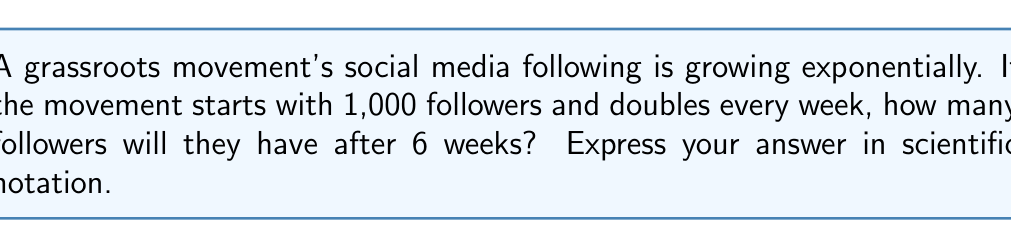Could you help me with this problem? Let's approach this step-by-step:

1) The initial number of followers is 1,000.

2) The number of followers doubles every week, which means we're multiplying by 2 each week.

3) This can be expressed as an exponential function:
   $f(t) = 1000 \cdot 2^t$, where $t$ is the number of weeks.

4) We want to know the number of followers after 6 weeks, so we substitute $t=6$:
   $f(6) = 1000 \cdot 2^6$

5) Let's calculate $2^6$:
   $2^6 = 2 \cdot 2 \cdot 2 \cdot 2 \cdot 2 \cdot 2 = 64$

6) Now we can complete the calculation:
   $f(6) = 1000 \cdot 64 = 64,000$

7) To express this in scientific notation, we move the decimal point 4 places to the left:
   $64,000 = 6.4 \times 10^4$

Therefore, after 6 weeks, the movement will have $6.4 \times 10^4$ followers.
Answer: $6.4 \times 10^4$ 